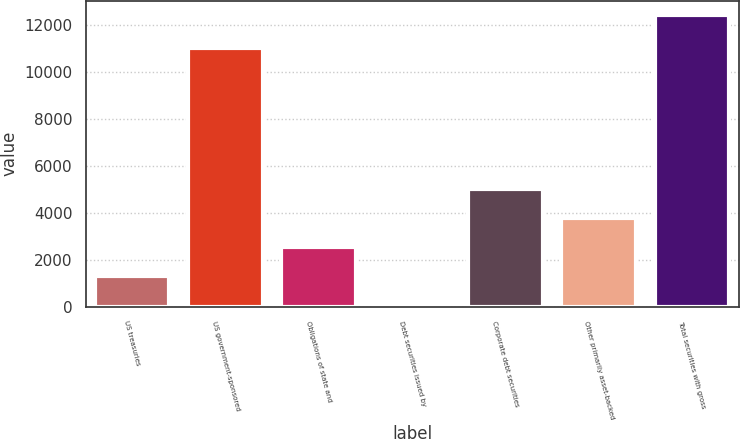<chart> <loc_0><loc_0><loc_500><loc_500><bar_chart><fcel>US treasuries<fcel>US government-sponsored<fcel>Obligations of state and<fcel>Debt securities issued by<fcel>Corporate debt securities<fcel>Other primarily asset-backed<fcel>Total securities with gross<nl><fcel>1304.9<fcel>11007<fcel>2538.8<fcel>71<fcel>5006.6<fcel>3772.7<fcel>12410<nl></chart> 